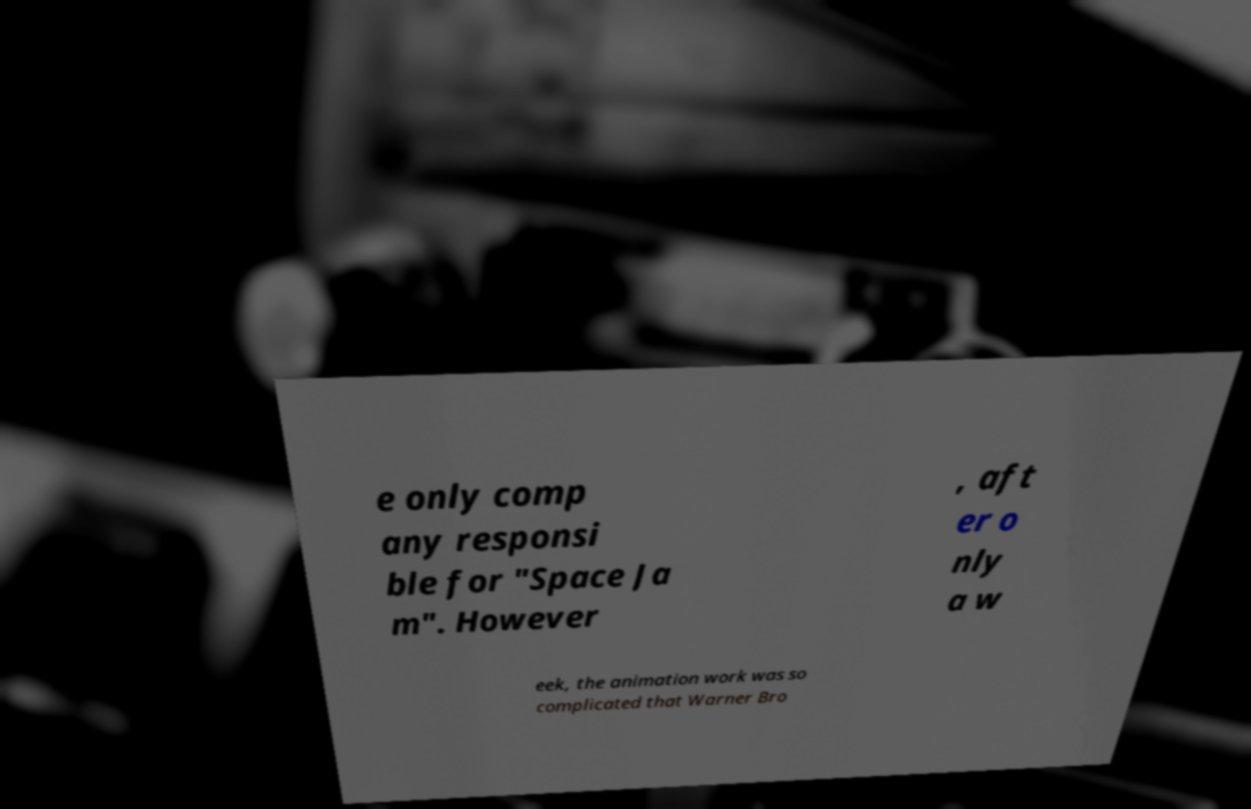Please read and relay the text visible in this image. What does it say? e only comp any responsi ble for "Space Ja m". However , aft er o nly a w eek, the animation work was so complicated that Warner Bro 